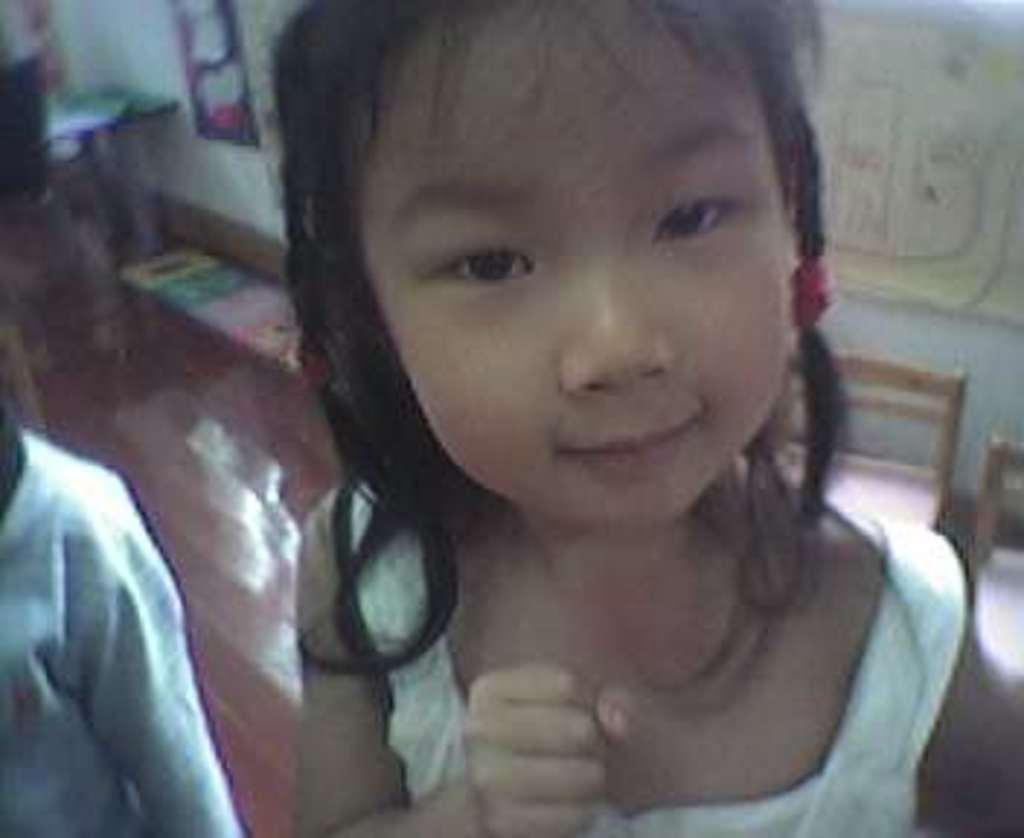Can you describe this image briefly? In this picture we can see a girl and a person on the left side. We can see a few colorful objects on the ground and on the wall. This is a blur image. 